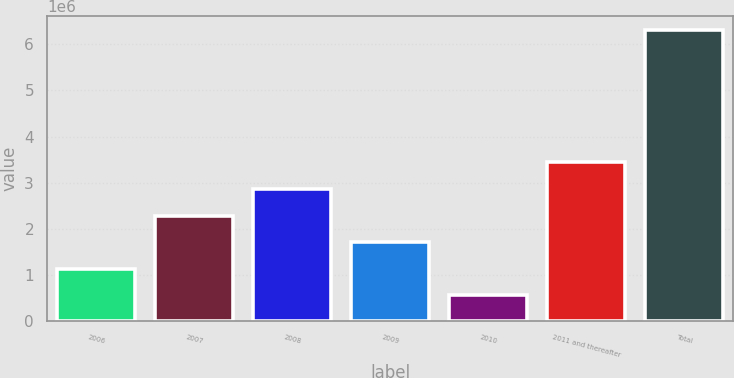Convert chart. <chart><loc_0><loc_0><loc_500><loc_500><bar_chart><fcel>2006<fcel>2007<fcel>2008<fcel>2009<fcel>2010<fcel>2011 and thereafter<fcel>Total<nl><fcel>1.13028e+06<fcel>2.28037e+06<fcel>2.85542e+06<fcel>1.70532e+06<fcel>555228<fcel>3.43968e+06<fcel>6.30571e+06<nl></chart> 